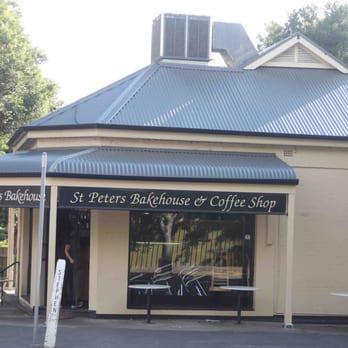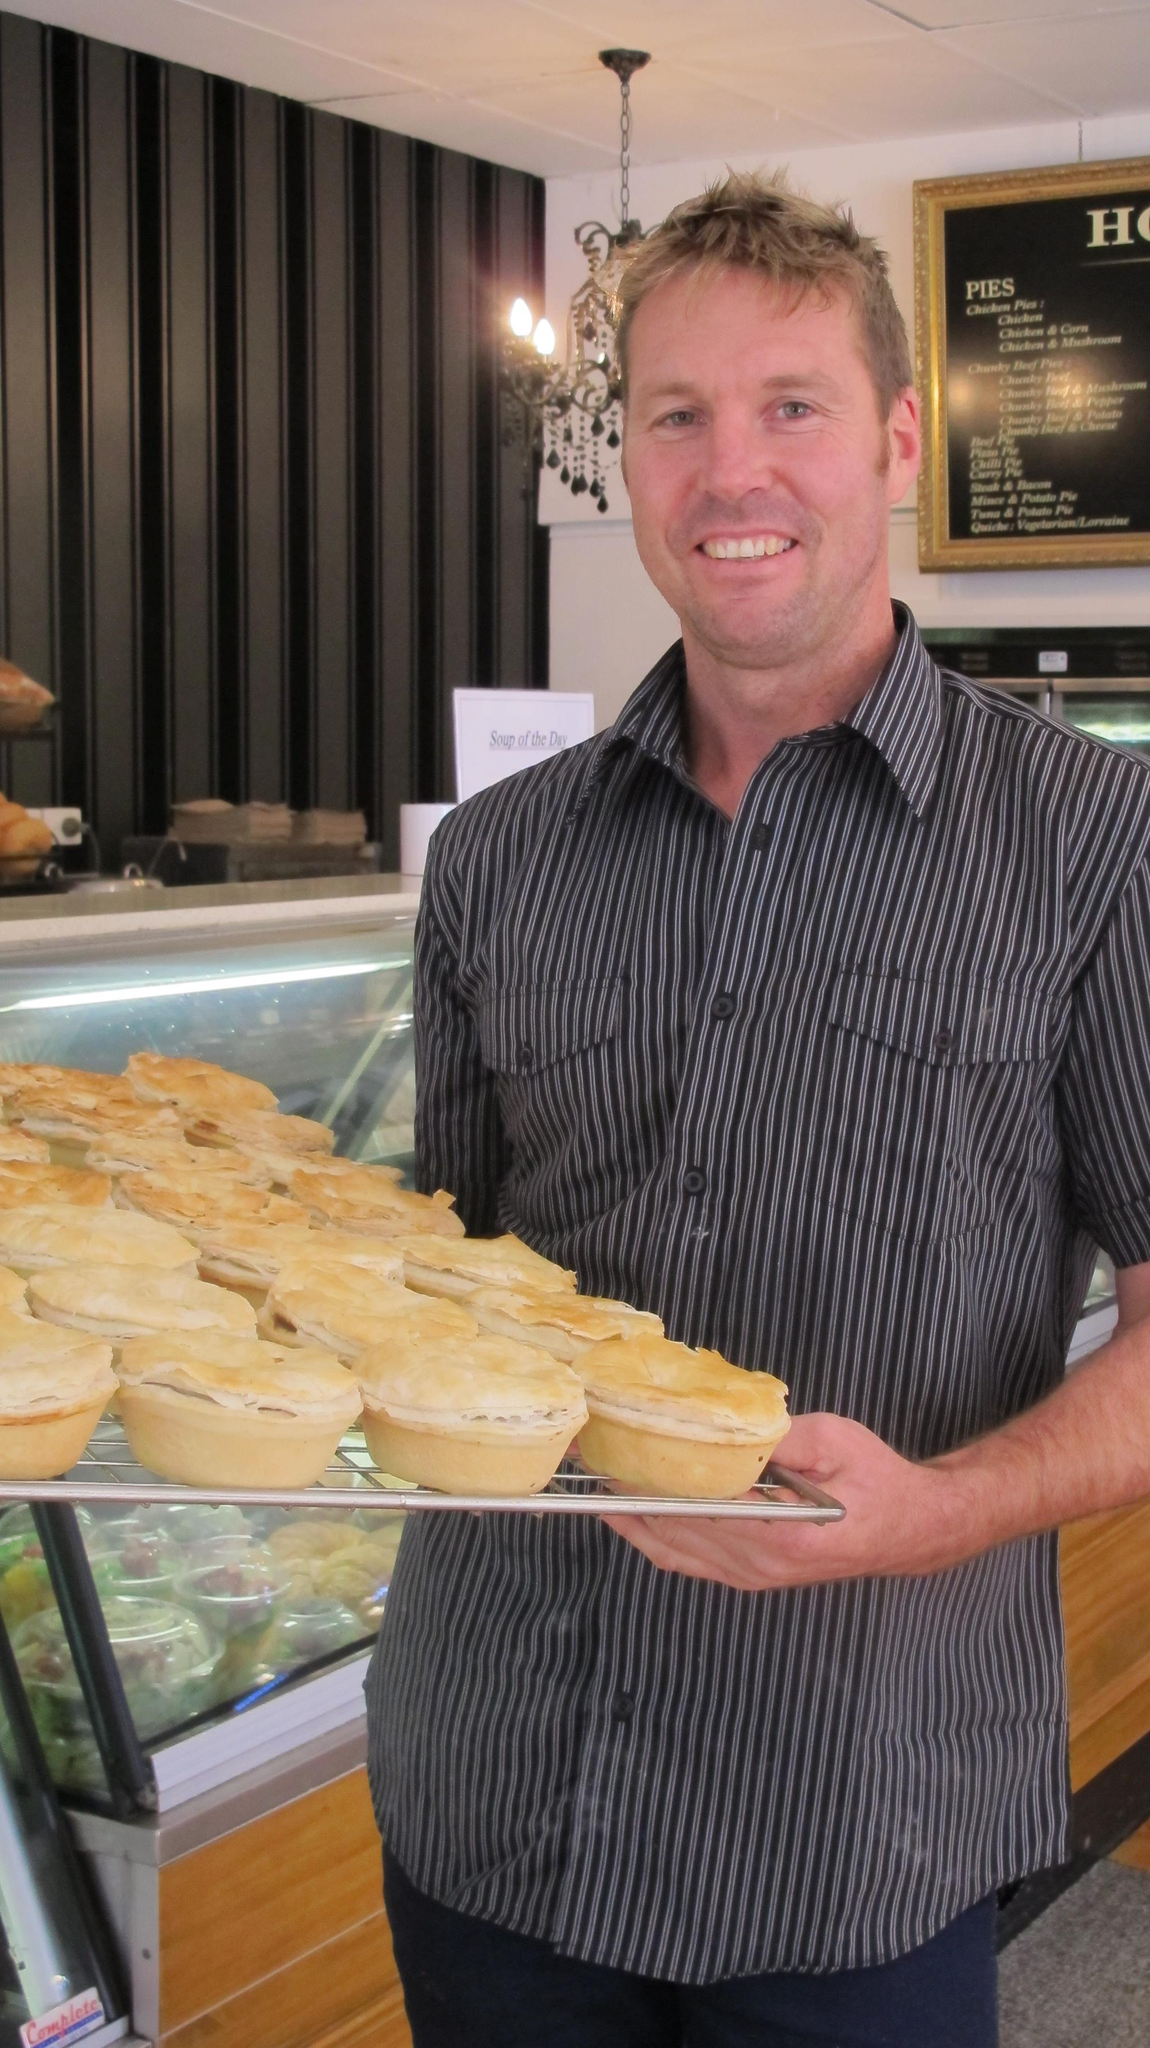The first image is the image on the left, the second image is the image on the right. Assess this claim about the two images: "We can see the outdoor seats to the restaurant.". Correct or not? Answer yes or no. No. 